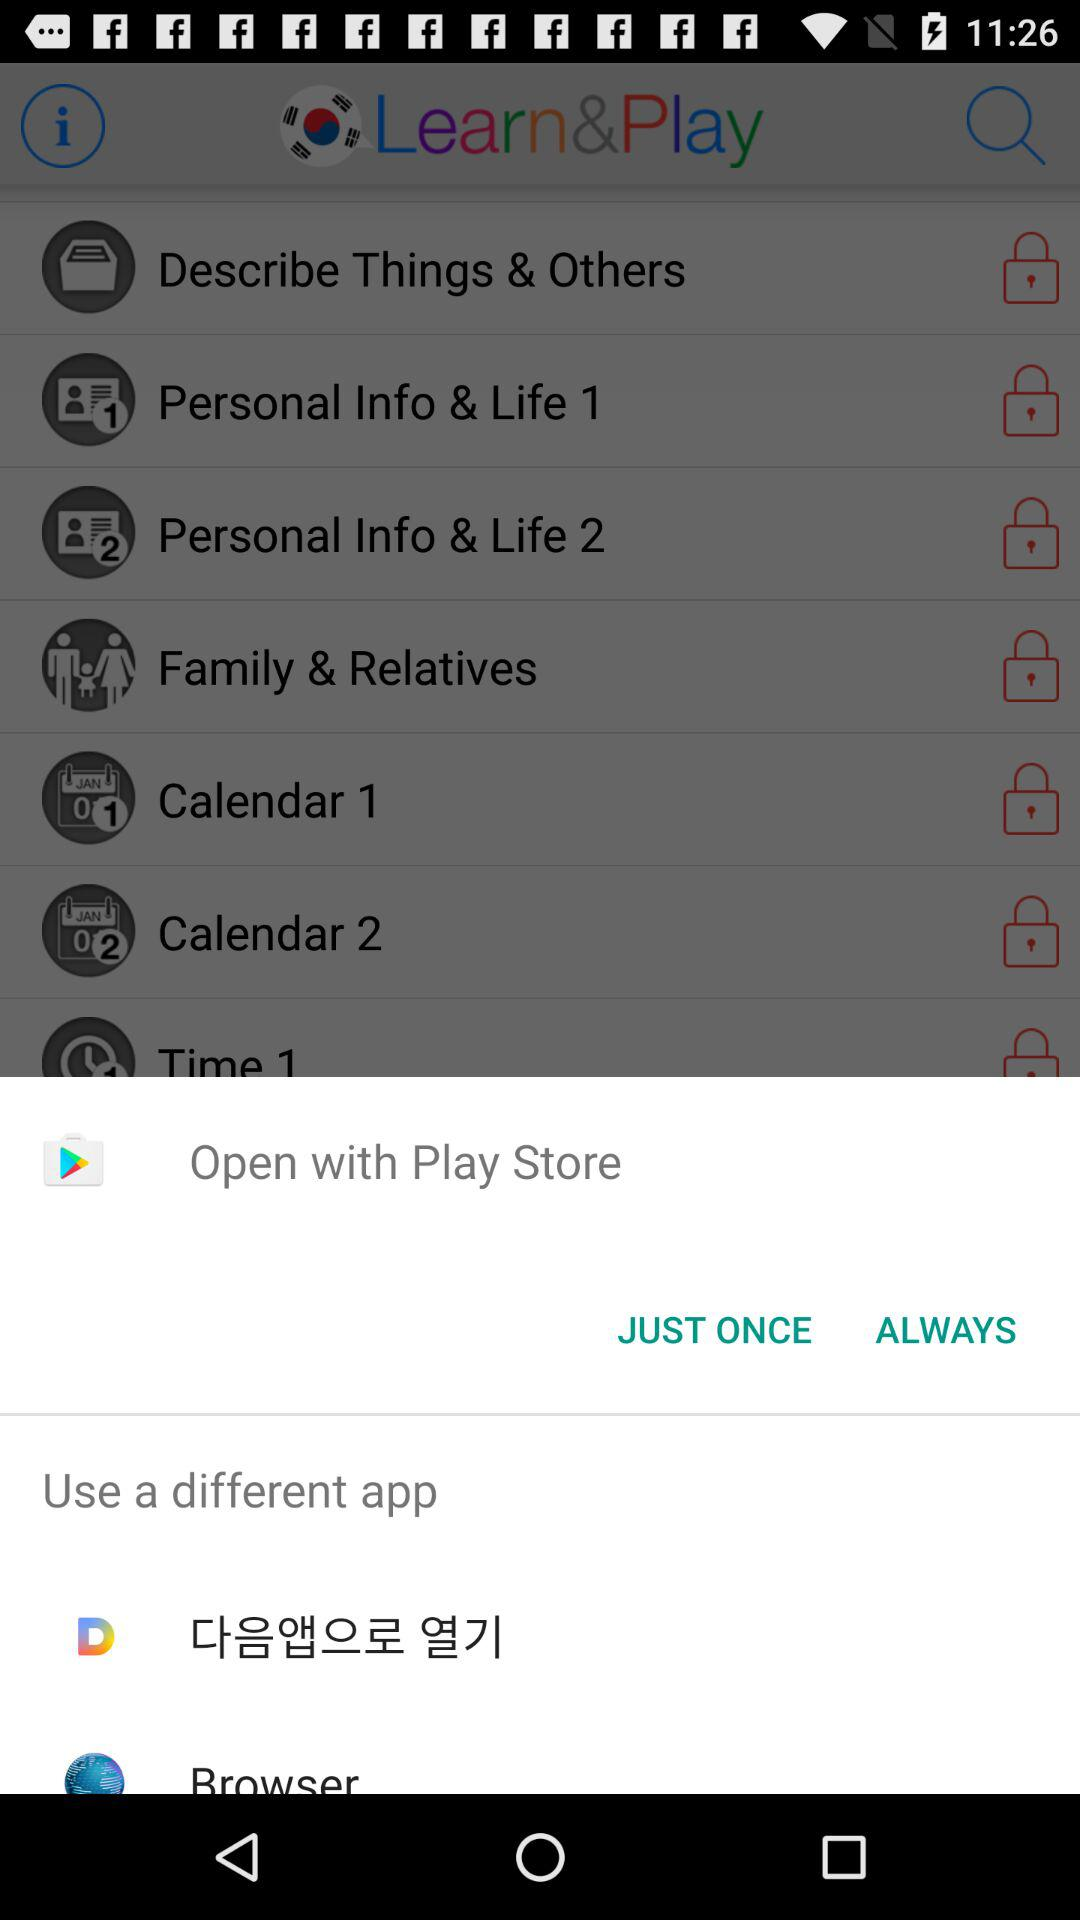What are the category names in "Learn&Play"? The category names are "Describe Things & Others", "Personal Info & Life 1", "Personal Info & Life 2:", "Family & Relatives", "Calendar 1", "Calendar 2" and "Time 1". 